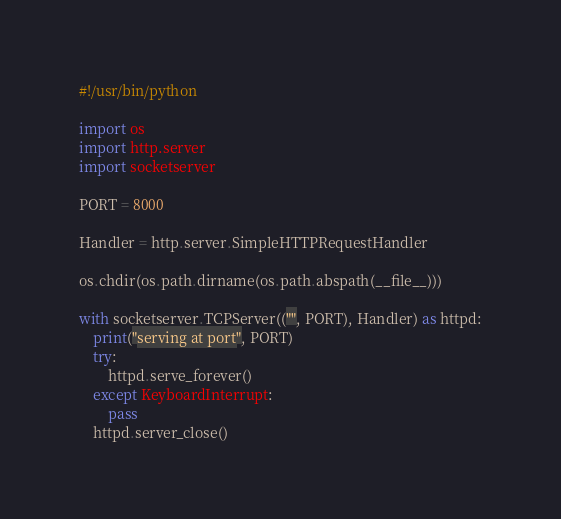<code> <loc_0><loc_0><loc_500><loc_500><_Python_>#!/usr/bin/python

import os
import http.server
import socketserver

PORT = 8000

Handler = http.server.SimpleHTTPRequestHandler

os.chdir(os.path.dirname(os.path.abspath(__file__)))

with socketserver.TCPServer(("", PORT), Handler) as httpd:
    print("serving at port", PORT)
    try:
        httpd.serve_forever()
    except KeyboardInterrupt:
        pass
    httpd.server_close()
</code> 